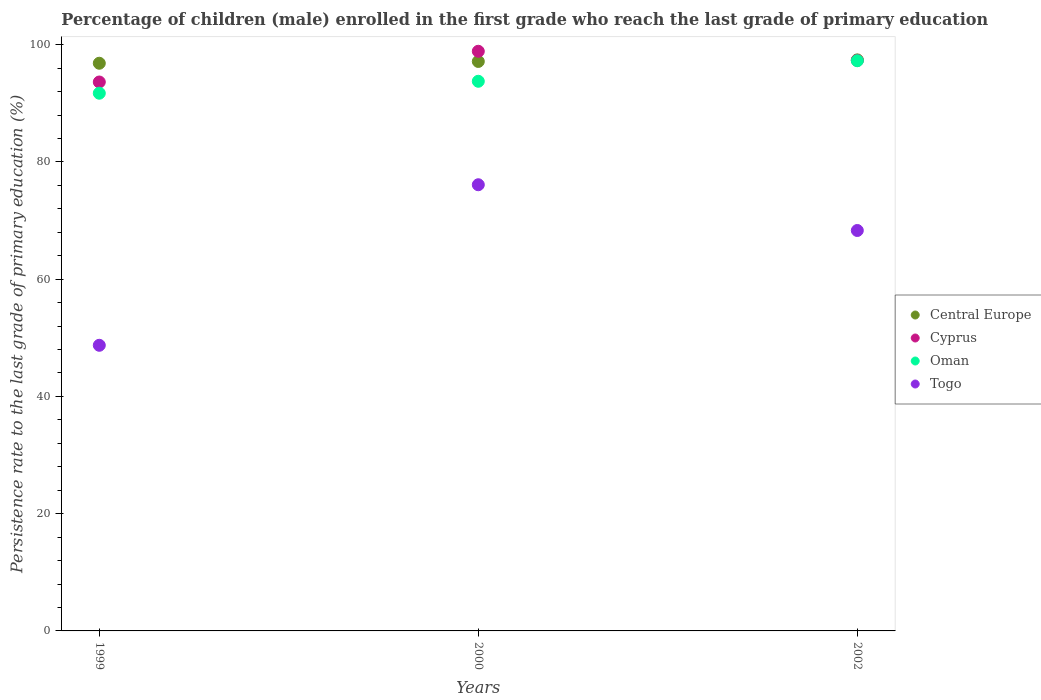How many different coloured dotlines are there?
Make the answer very short. 4. Is the number of dotlines equal to the number of legend labels?
Make the answer very short. Yes. What is the persistence rate of children in Oman in 2000?
Your answer should be very brief. 93.76. Across all years, what is the maximum persistence rate of children in Oman?
Your response must be concise. 97.26. Across all years, what is the minimum persistence rate of children in Cyprus?
Make the answer very short. 93.63. What is the total persistence rate of children in Oman in the graph?
Your answer should be very brief. 282.74. What is the difference between the persistence rate of children in Central Europe in 1999 and that in 2000?
Keep it short and to the point. -0.31. What is the difference between the persistence rate of children in Oman in 1999 and the persistence rate of children in Togo in 2000?
Your response must be concise. 15.61. What is the average persistence rate of children in Togo per year?
Make the answer very short. 64.38. In the year 2000, what is the difference between the persistence rate of children in Oman and persistence rate of children in Togo?
Your answer should be compact. 17.65. In how many years, is the persistence rate of children in Oman greater than 20 %?
Your response must be concise. 3. What is the ratio of the persistence rate of children in Cyprus in 1999 to that in 2002?
Provide a short and direct response. 0.96. Is the persistence rate of children in Cyprus in 1999 less than that in 2000?
Ensure brevity in your answer.  Yes. What is the difference between the highest and the second highest persistence rate of children in Togo?
Your answer should be compact. 7.8. What is the difference between the highest and the lowest persistence rate of children in Togo?
Give a very brief answer. 27.39. In how many years, is the persistence rate of children in Togo greater than the average persistence rate of children in Togo taken over all years?
Your answer should be very brief. 2. Is the sum of the persistence rate of children in Oman in 1999 and 2000 greater than the maximum persistence rate of children in Cyprus across all years?
Provide a succinct answer. Yes. Is it the case that in every year, the sum of the persistence rate of children in Oman and persistence rate of children in Togo  is greater than the sum of persistence rate of children in Central Europe and persistence rate of children in Cyprus?
Keep it short and to the point. Yes. Does the persistence rate of children in Togo monotonically increase over the years?
Provide a short and direct response. No. Is the persistence rate of children in Oman strictly greater than the persistence rate of children in Togo over the years?
Provide a short and direct response. Yes. Is the persistence rate of children in Togo strictly less than the persistence rate of children in Oman over the years?
Your answer should be very brief. Yes. How many years are there in the graph?
Your response must be concise. 3. Does the graph contain any zero values?
Offer a terse response. No. Where does the legend appear in the graph?
Provide a short and direct response. Center right. How many legend labels are there?
Your response must be concise. 4. How are the legend labels stacked?
Offer a very short reply. Vertical. What is the title of the graph?
Your response must be concise. Percentage of children (male) enrolled in the first grade who reach the last grade of primary education. Does "Europe(all income levels)" appear as one of the legend labels in the graph?
Your answer should be very brief. No. What is the label or title of the X-axis?
Provide a succinct answer. Years. What is the label or title of the Y-axis?
Offer a very short reply. Persistence rate to the last grade of primary education (%). What is the Persistence rate to the last grade of primary education (%) of Central Europe in 1999?
Provide a succinct answer. 96.83. What is the Persistence rate to the last grade of primary education (%) in Cyprus in 1999?
Provide a succinct answer. 93.63. What is the Persistence rate to the last grade of primary education (%) in Oman in 1999?
Give a very brief answer. 91.72. What is the Persistence rate to the last grade of primary education (%) in Togo in 1999?
Your answer should be very brief. 48.72. What is the Persistence rate to the last grade of primary education (%) in Central Europe in 2000?
Provide a short and direct response. 97.14. What is the Persistence rate to the last grade of primary education (%) in Cyprus in 2000?
Make the answer very short. 98.88. What is the Persistence rate to the last grade of primary education (%) in Oman in 2000?
Ensure brevity in your answer.  93.76. What is the Persistence rate to the last grade of primary education (%) of Togo in 2000?
Give a very brief answer. 76.11. What is the Persistence rate to the last grade of primary education (%) of Central Europe in 2002?
Offer a very short reply. 97.41. What is the Persistence rate to the last grade of primary education (%) of Cyprus in 2002?
Give a very brief answer. 97.32. What is the Persistence rate to the last grade of primary education (%) in Oman in 2002?
Give a very brief answer. 97.26. What is the Persistence rate to the last grade of primary education (%) in Togo in 2002?
Offer a very short reply. 68.3. Across all years, what is the maximum Persistence rate to the last grade of primary education (%) of Central Europe?
Provide a short and direct response. 97.41. Across all years, what is the maximum Persistence rate to the last grade of primary education (%) of Cyprus?
Your answer should be compact. 98.88. Across all years, what is the maximum Persistence rate to the last grade of primary education (%) in Oman?
Give a very brief answer. 97.26. Across all years, what is the maximum Persistence rate to the last grade of primary education (%) in Togo?
Ensure brevity in your answer.  76.11. Across all years, what is the minimum Persistence rate to the last grade of primary education (%) in Central Europe?
Make the answer very short. 96.83. Across all years, what is the minimum Persistence rate to the last grade of primary education (%) of Cyprus?
Make the answer very short. 93.63. Across all years, what is the minimum Persistence rate to the last grade of primary education (%) in Oman?
Your response must be concise. 91.72. Across all years, what is the minimum Persistence rate to the last grade of primary education (%) in Togo?
Ensure brevity in your answer.  48.72. What is the total Persistence rate to the last grade of primary education (%) in Central Europe in the graph?
Give a very brief answer. 291.38. What is the total Persistence rate to the last grade of primary education (%) in Cyprus in the graph?
Keep it short and to the point. 289.83. What is the total Persistence rate to the last grade of primary education (%) in Oman in the graph?
Provide a short and direct response. 282.74. What is the total Persistence rate to the last grade of primary education (%) in Togo in the graph?
Make the answer very short. 193.14. What is the difference between the Persistence rate to the last grade of primary education (%) of Central Europe in 1999 and that in 2000?
Your response must be concise. -0.31. What is the difference between the Persistence rate to the last grade of primary education (%) in Cyprus in 1999 and that in 2000?
Provide a short and direct response. -5.24. What is the difference between the Persistence rate to the last grade of primary education (%) in Oman in 1999 and that in 2000?
Offer a very short reply. -2.04. What is the difference between the Persistence rate to the last grade of primary education (%) in Togo in 1999 and that in 2000?
Your answer should be very brief. -27.39. What is the difference between the Persistence rate to the last grade of primary education (%) of Central Europe in 1999 and that in 2002?
Make the answer very short. -0.57. What is the difference between the Persistence rate to the last grade of primary education (%) of Cyprus in 1999 and that in 2002?
Offer a terse response. -3.69. What is the difference between the Persistence rate to the last grade of primary education (%) of Oman in 1999 and that in 2002?
Provide a short and direct response. -5.54. What is the difference between the Persistence rate to the last grade of primary education (%) in Togo in 1999 and that in 2002?
Provide a succinct answer. -19.58. What is the difference between the Persistence rate to the last grade of primary education (%) of Central Europe in 2000 and that in 2002?
Make the answer very short. -0.27. What is the difference between the Persistence rate to the last grade of primary education (%) of Cyprus in 2000 and that in 2002?
Your answer should be very brief. 1.55. What is the difference between the Persistence rate to the last grade of primary education (%) of Oman in 2000 and that in 2002?
Provide a succinct answer. -3.5. What is the difference between the Persistence rate to the last grade of primary education (%) of Togo in 2000 and that in 2002?
Provide a short and direct response. 7.8. What is the difference between the Persistence rate to the last grade of primary education (%) of Central Europe in 1999 and the Persistence rate to the last grade of primary education (%) of Cyprus in 2000?
Provide a succinct answer. -2.04. What is the difference between the Persistence rate to the last grade of primary education (%) of Central Europe in 1999 and the Persistence rate to the last grade of primary education (%) of Oman in 2000?
Make the answer very short. 3.08. What is the difference between the Persistence rate to the last grade of primary education (%) of Central Europe in 1999 and the Persistence rate to the last grade of primary education (%) of Togo in 2000?
Give a very brief answer. 20.72. What is the difference between the Persistence rate to the last grade of primary education (%) in Cyprus in 1999 and the Persistence rate to the last grade of primary education (%) in Oman in 2000?
Your response must be concise. -0.12. What is the difference between the Persistence rate to the last grade of primary education (%) of Cyprus in 1999 and the Persistence rate to the last grade of primary education (%) of Togo in 2000?
Provide a short and direct response. 17.53. What is the difference between the Persistence rate to the last grade of primary education (%) in Oman in 1999 and the Persistence rate to the last grade of primary education (%) in Togo in 2000?
Provide a short and direct response. 15.61. What is the difference between the Persistence rate to the last grade of primary education (%) in Central Europe in 1999 and the Persistence rate to the last grade of primary education (%) in Cyprus in 2002?
Give a very brief answer. -0.49. What is the difference between the Persistence rate to the last grade of primary education (%) of Central Europe in 1999 and the Persistence rate to the last grade of primary education (%) of Oman in 2002?
Provide a short and direct response. -0.43. What is the difference between the Persistence rate to the last grade of primary education (%) of Central Europe in 1999 and the Persistence rate to the last grade of primary education (%) of Togo in 2002?
Provide a succinct answer. 28.53. What is the difference between the Persistence rate to the last grade of primary education (%) of Cyprus in 1999 and the Persistence rate to the last grade of primary education (%) of Oman in 2002?
Your answer should be very brief. -3.63. What is the difference between the Persistence rate to the last grade of primary education (%) in Cyprus in 1999 and the Persistence rate to the last grade of primary education (%) in Togo in 2002?
Make the answer very short. 25.33. What is the difference between the Persistence rate to the last grade of primary education (%) in Oman in 1999 and the Persistence rate to the last grade of primary education (%) in Togo in 2002?
Your response must be concise. 23.42. What is the difference between the Persistence rate to the last grade of primary education (%) in Central Europe in 2000 and the Persistence rate to the last grade of primary education (%) in Cyprus in 2002?
Ensure brevity in your answer.  -0.18. What is the difference between the Persistence rate to the last grade of primary education (%) in Central Europe in 2000 and the Persistence rate to the last grade of primary education (%) in Oman in 2002?
Provide a succinct answer. -0.12. What is the difference between the Persistence rate to the last grade of primary education (%) of Central Europe in 2000 and the Persistence rate to the last grade of primary education (%) of Togo in 2002?
Ensure brevity in your answer.  28.84. What is the difference between the Persistence rate to the last grade of primary education (%) of Cyprus in 2000 and the Persistence rate to the last grade of primary education (%) of Oman in 2002?
Ensure brevity in your answer.  1.62. What is the difference between the Persistence rate to the last grade of primary education (%) in Cyprus in 2000 and the Persistence rate to the last grade of primary education (%) in Togo in 2002?
Your response must be concise. 30.57. What is the difference between the Persistence rate to the last grade of primary education (%) of Oman in 2000 and the Persistence rate to the last grade of primary education (%) of Togo in 2002?
Keep it short and to the point. 25.45. What is the average Persistence rate to the last grade of primary education (%) of Central Europe per year?
Your answer should be very brief. 97.13. What is the average Persistence rate to the last grade of primary education (%) of Cyprus per year?
Ensure brevity in your answer.  96.61. What is the average Persistence rate to the last grade of primary education (%) of Oman per year?
Ensure brevity in your answer.  94.25. What is the average Persistence rate to the last grade of primary education (%) of Togo per year?
Provide a succinct answer. 64.38. In the year 1999, what is the difference between the Persistence rate to the last grade of primary education (%) in Central Europe and Persistence rate to the last grade of primary education (%) in Cyprus?
Your answer should be very brief. 3.2. In the year 1999, what is the difference between the Persistence rate to the last grade of primary education (%) in Central Europe and Persistence rate to the last grade of primary education (%) in Oman?
Offer a very short reply. 5.11. In the year 1999, what is the difference between the Persistence rate to the last grade of primary education (%) in Central Europe and Persistence rate to the last grade of primary education (%) in Togo?
Your response must be concise. 48.11. In the year 1999, what is the difference between the Persistence rate to the last grade of primary education (%) in Cyprus and Persistence rate to the last grade of primary education (%) in Oman?
Keep it short and to the point. 1.91. In the year 1999, what is the difference between the Persistence rate to the last grade of primary education (%) of Cyprus and Persistence rate to the last grade of primary education (%) of Togo?
Provide a short and direct response. 44.91. In the year 1999, what is the difference between the Persistence rate to the last grade of primary education (%) in Oman and Persistence rate to the last grade of primary education (%) in Togo?
Give a very brief answer. 43. In the year 2000, what is the difference between the Persistence rate to the last grade of primary education (%) of Central Europe and Persistence rate to the last grade of primary education (%) of Cyprus?
Give a very brief answer. -1.74. In the year 2000, what is the difference between the Persistence rate to the last grade of primary education (%) in Central Europe and Persistence rate to the last grade of primary education (%) in Oman?
Keep it short and to the point. 3.38. In the year 2000, what is the difference between the Persistence rate to the last grade of primary education (%) of Central Europe and Persistence rate to the last grade of primary education (%) of Togo?
Offer a terse response. 21.03. In the year 2000, what is the difference between the Persistence rate to the last grade of primary education (%) of Cyprus and Persistence rate to the last grade of primary education (%) of Oman?
Offer a very short reply. 5.12. In the year 2000, what is the difference between the Persistence rate to the last grade of primary education (%) in Cyprus and Persistence rate to the last grade of primary education (%) in Togo?
Your response must be concise. 22.77. In the year 2000, what is the difference between the Persistence rate to the last grade of primary education (%) of Oman and Persistence rate to the last grade of primary education (%) of Togo?
Give a very brief answer. 17.65. In the year 2002, what is the difference between the Persistence rate to the last grade of primary education (%) of Central Europe and Persistence rate to the last grade of primary education (%) of Cyprus?
Your answer should be very brief. 0.09. In the year 2002, what is the difference between the Persistence rate to the last grade of primary education (%) of Central Europe and Persistence rate to the last grade of primary education (%) of Oman?
Provide a succinct answer. 0.15. In the year 2002, what is the difference between the Persistence rate to the last grade of primary education (%) in Central Europe and Persistence rate to the last grade of primary education (%) in Togo?
Make the answer very short. 29.1. In the year 2002, what is the difference between the Persistence rate to the last grade of primary education (%) of Cyprus and Persistence rate to the last grade of primary education (%) of Oman?
Offer a very short reply. 0.06. In the year 2002, what is the difference between the Persistence rate to the last grade of primary education (%) of Cyprus and Persistence rate to the last grade of primary education (%) of Togo?
Offer a terse response. 29.02. In the year 2002, what is the difference between the Persistence rate to the last grade of primary education (%) of Oman and Persistence rate to the last grade of primary education (%) of Togo?
Provide a succinct answer. 28.96. What is the ratio of the Persistence rate to the last grade of primary education (%) in Cyprus in 1999 to that in 2000?
Keep it short and to the point. 0.95. What is the ratio of the Persistence rate to the last grade of primary education (%) of Oman in 1999 to that in 2000?
Give a very brief answer. 0.98. What is the ratio of the Persistence rate to the last grade of primary education (%) of Togo in 1999 to that in 2000?
Ensure brevity in your answer.  0.64. What is the ratio of the Persistence rate to the last grade of primary education (%) in Cyprus in 1999 to that in 2002?
Your answer should be very brief. 0.96. What is the ratio of the Persistence rate to the last grade of primary education (%) in Oman in 1999 to that in 2002?
Your answer should be compact. 0.94. What is the ratio of the Persistence rate to the last grade of primary education (%) of Togo in 1999 to that in 2002?
Make the answer very short. 0.71. What is the ratio of the Persistence rate to the last grade of primary education (%) in Central Europe in 2000 to that in 2002?
Give a very brief answer. 1. What is the ratio of the Persistence rate to the last grade of primary education (%) in Oman in 2000 to that in 2002?
Your response must be concise. 0.96. What is the ratio of the Persistence rate to the last grade of primary education (%) in Togo in 2000 to that in 2002?
Provide a succinct answer. 1.11. What is the difference between the highest and the second highest Persistence rate to the last grade of primary education (%) in Central Europe?
Your answer should be compact. 0.27. What is the difference between the highest and the second highest Persistence rate to the last grade of primary education (%) of Cyprus?
Your answer should be very brief. 1.55. What is the difference between the highest and the second highest Persistence rate to the last grade of primary education (%) of Oman?
Ensure brevity in your answer.  3.5. What is the difference between the highest and the second highest Persistence rate to the last grade of primary education (%) of Togo?
Make the answer very short. 7.8. What is the difference between the highest and the lowest Persistence rate to the last grade of primary education (%) in Central Europe?
Keep it short and to the point. 0.57. What is the difference between the highest and the lowest Persistence rate to the last grade of primary education (%) in Cyprus?
Provide a succinct answer. 5.24. What is the difference between the highest and the lowest Persistence rate to the last grade of primary education (%) of Oman?
Give a very brief answer. 5.54. What is the difference between the highest and the lowest Persistence rate to the last grade of primary education (%) of Togo?
Your answer should be very brief. 27.39. 